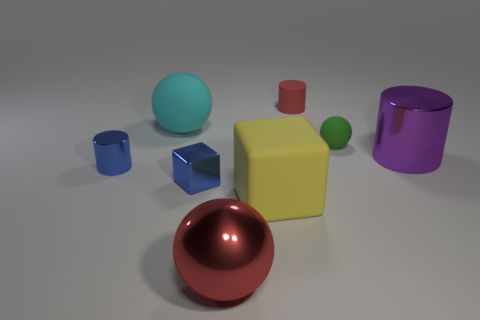Add 1 tiny rubber balls. How many objects exist? 9 Subtract all blocks. How many objects are left? 6 Subtract all small cylinders. Subtract all small cyan metallic spheres. How many objects are left? 6 Add 1 big cylinders. How many big cylinders are left? 2 Add 5 tiny red matte cylinders. How many tiny red matte cylinders exist? 6 Subtract 1 purple cylinders. How many objects are left? 7 